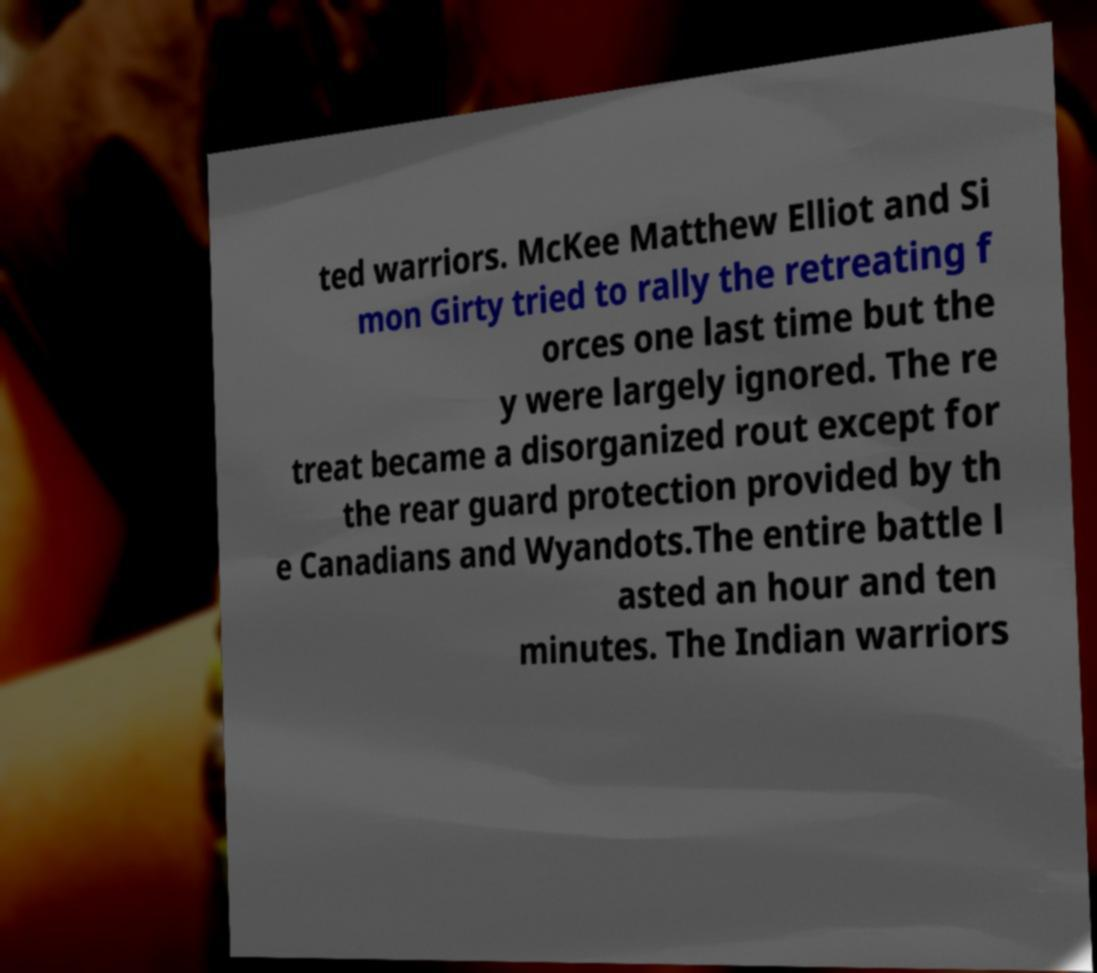I need the written content from this picture converted into text. Can you do that? ted warriors. McKee Matthew Elliot and Si mon Girty tried to rally the retreating f orces one last time but the y were largely ignored. The re treat became a disorganized rout except for the rear guard protection provided by th e Canadians and Wyandots.The entire battle l asted an hour and ten minutes. The Indian warriors 